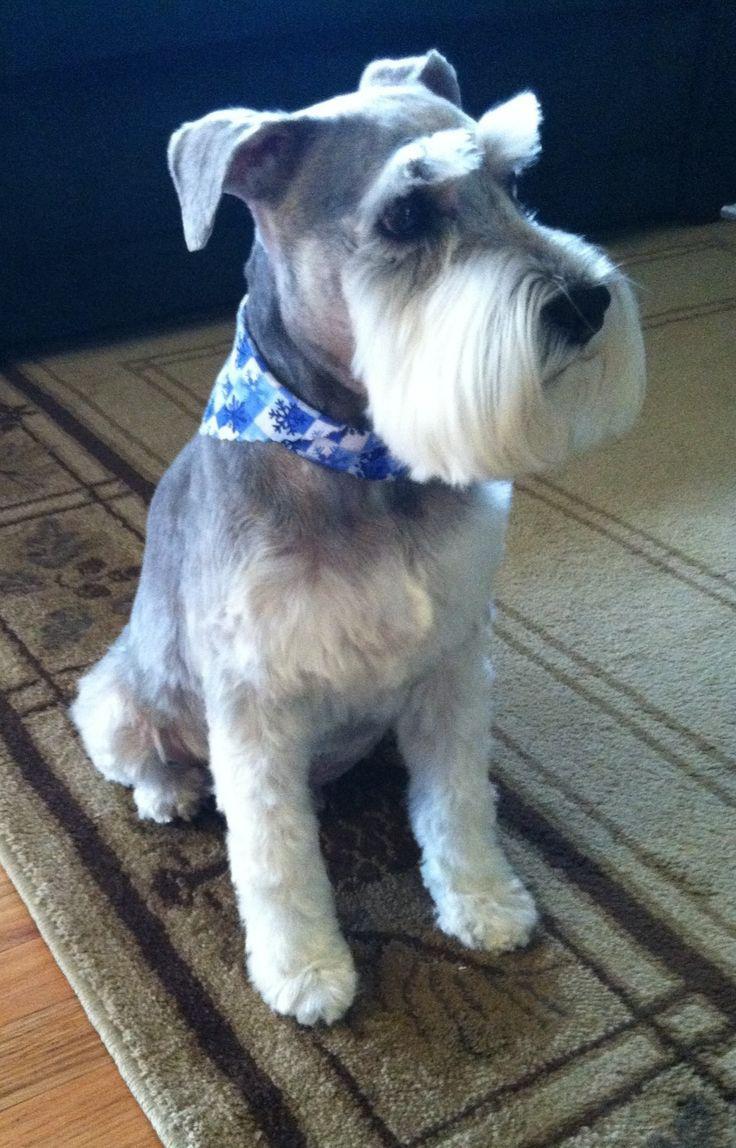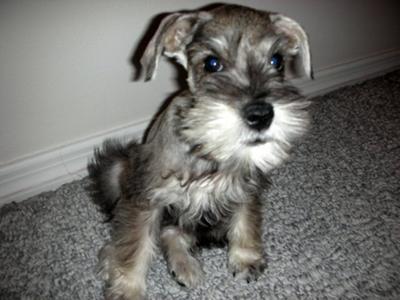The first image is the image on the left, the second image is the image on the right. Considering the images on both sides, is "There are two dogs sitting down." valid? Answer yes or no. Yes. The first image is the image on the left, the second image is the image on the right. Assess this claim about the two images: "There is a dog wearing a collar and facing left in one image.". Correct or not? Answer yes or no. No. 